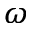Convert formula to latex. <formula><loc_0><loc_0><loc_500><loc_500>\omega</formula> 